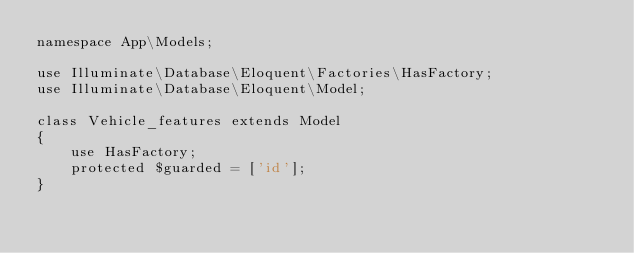<code> <loc_0><loc_0><loc_500><loc_500><_PHP_>namespace App\Models;

use Illuminate\Database\Eloquent\Factories\HasFactory;
use Illuminate\Database\Eloquent\Model;

class Vehicle_features extends Model
{
    use HasFactory;
    protected $guarded = ['id'];
}
</code> 